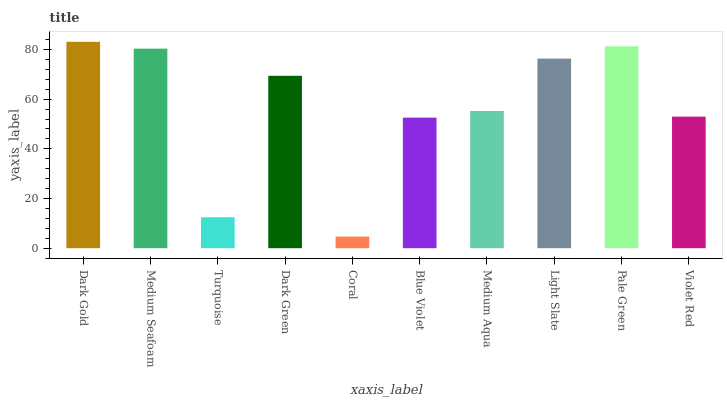Is Coral the minimum?
Answer yes or no. Yes. Is Dark Gold the maximum?
Answer yes or no. Yes. Is Medium Seafoam the minimum?
Answer yes or no. No. Is Medium Seafoam the maximum?
Answer yes or no. No. Is Dark Gold greater than Medium Seafoam?
Answer yes or no. Yes. Is Medium Seafoam less than Dark Gold?
Answer yes or no. Yes. Is Medium Seafoam greater than Dark Gold?
Answer yes or no. No. Is Dark Gold less than Medium Seafoam?
Answer yes or no. No. Is Dark Green the high median?
Answer yes or no. Yes. Is Medium Aqua the low median?
Answer yes or no. Yes. Is Pale Green the high median?
Answer yes or no. No. Is Blue Violet the low median?
Answer yes or no. No. 